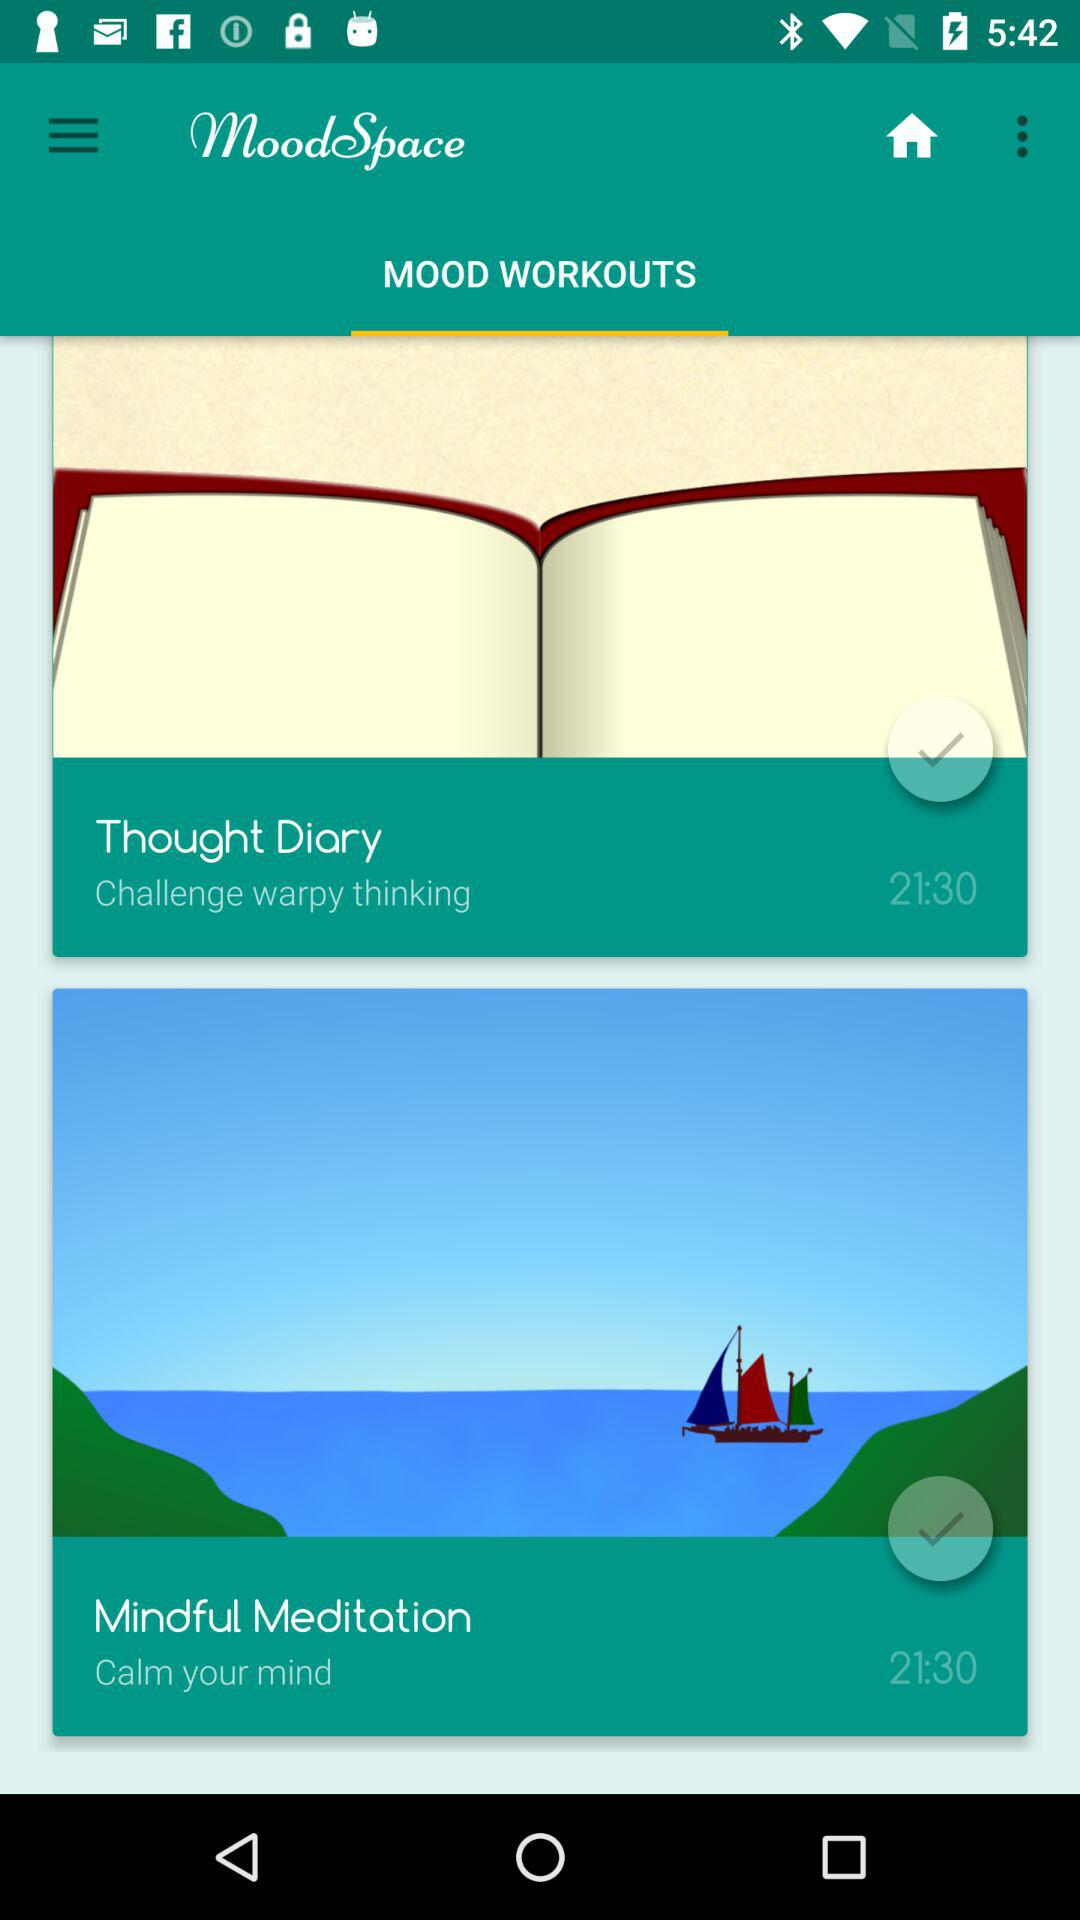How many mood workouts are there?
Answer the question using a single word or phrase. 2 